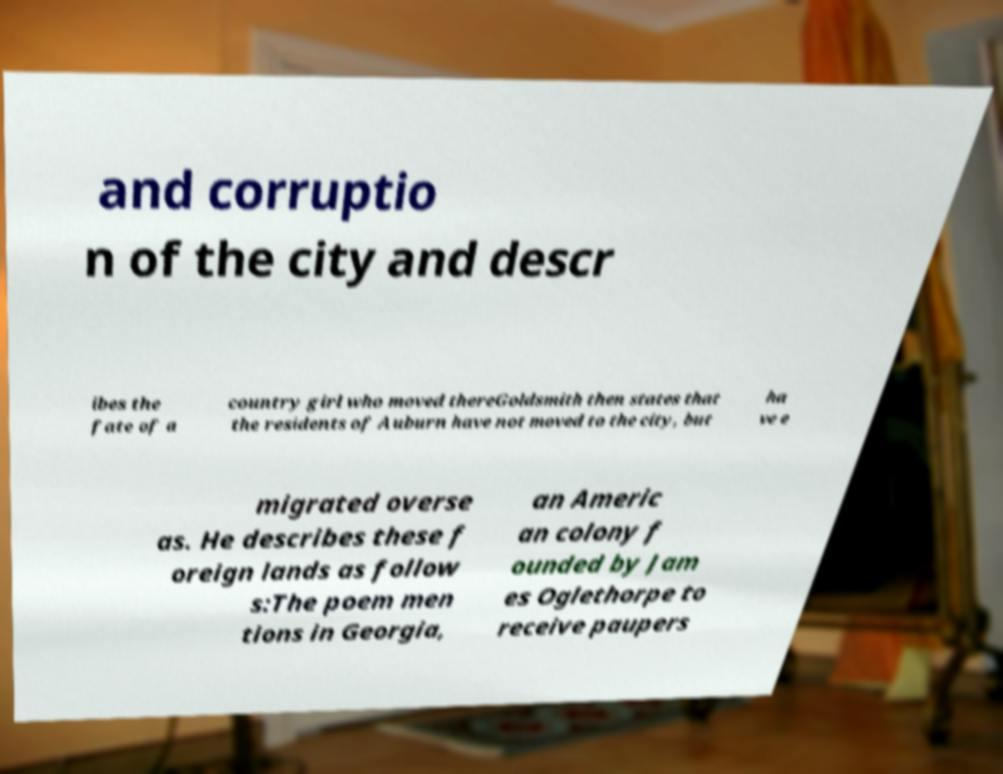Could you extract and type out the text from this image? and corruptio n of the city and descr ibes the fate of a country girl who moved thereGoldsmith then states that the residents of Auburn have not moved to the city, but ha ve e migrated overse as. He describes these f oreign lands as follow s:The poem men tions in Georgia, an Americ an colony f ounded by Jam es Oglethorpe to receive paupers 